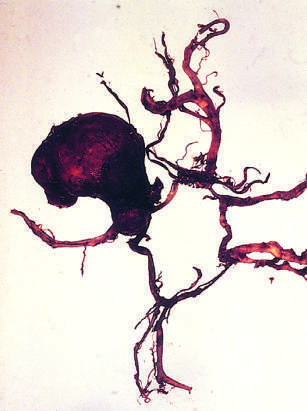what is dissected to show a large aneurysm?
Answer the question using a single word or phrase. View of the base of the brain 